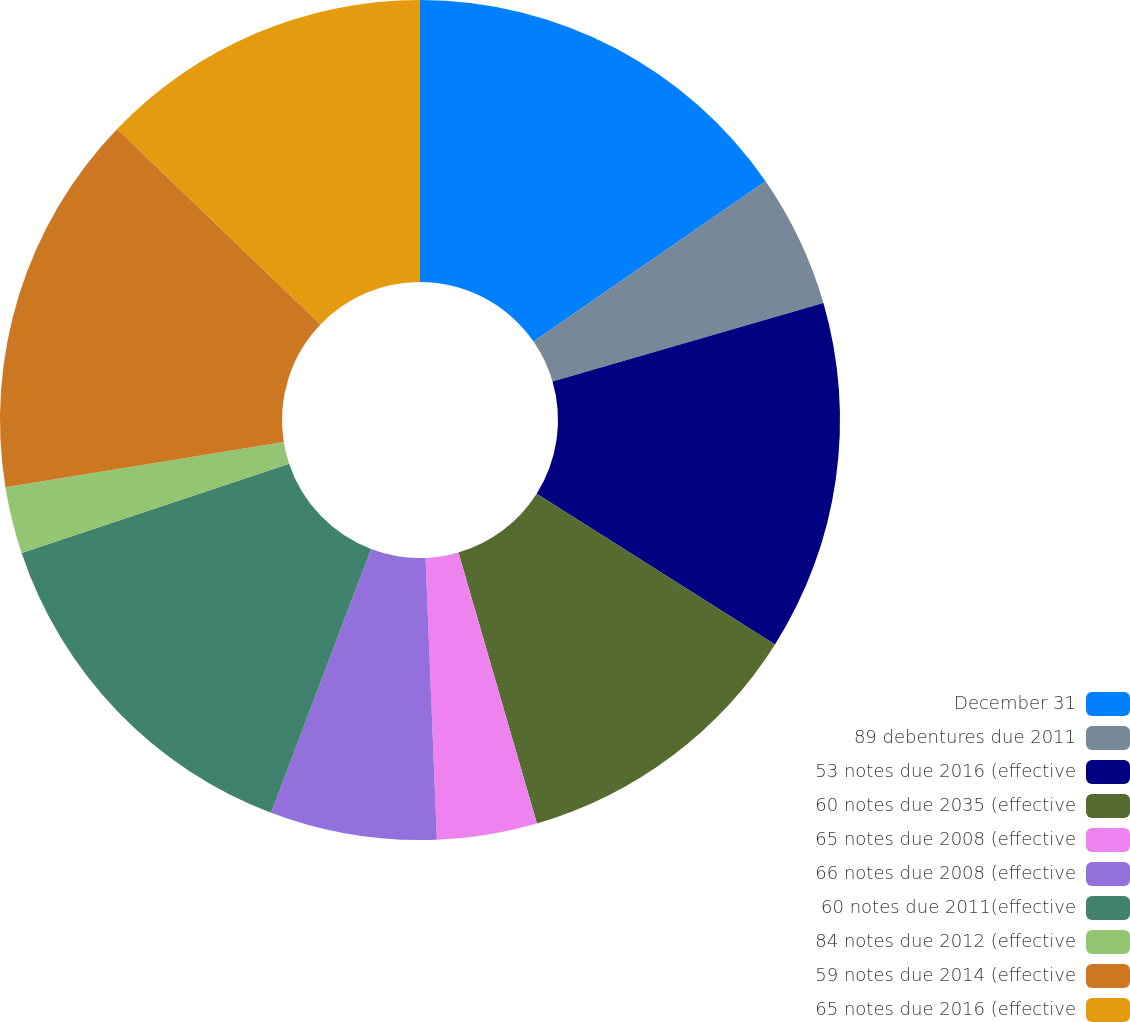Convert chart. <chart><loc_0><loc_0><loc_500><loc_500><pie_chart><fcel>December 31<fcel>89 debentures due 2011<fcel>53 notes due 2016 (effective<fcel>60 notes due 2035 (effective<fcel>65 notes due 2008 (effective<fcel>66 notes due 2008 (effective<fcel>60 notes due 2011(effective<fcel>84 notes due 2012 (effective<fcel>59 notes due 2014 (effective<fcel>65 notes due 2016 (effective<nl><fcel>15.38%<fcel>5.13%<fcel>13.46%<fcel>11.54%<fcel>3.85%<fcel>6.41%<fcel>14.1%<fcel>2.57%<fcel>14.74%<fcel>12.82%<nl></chart> 